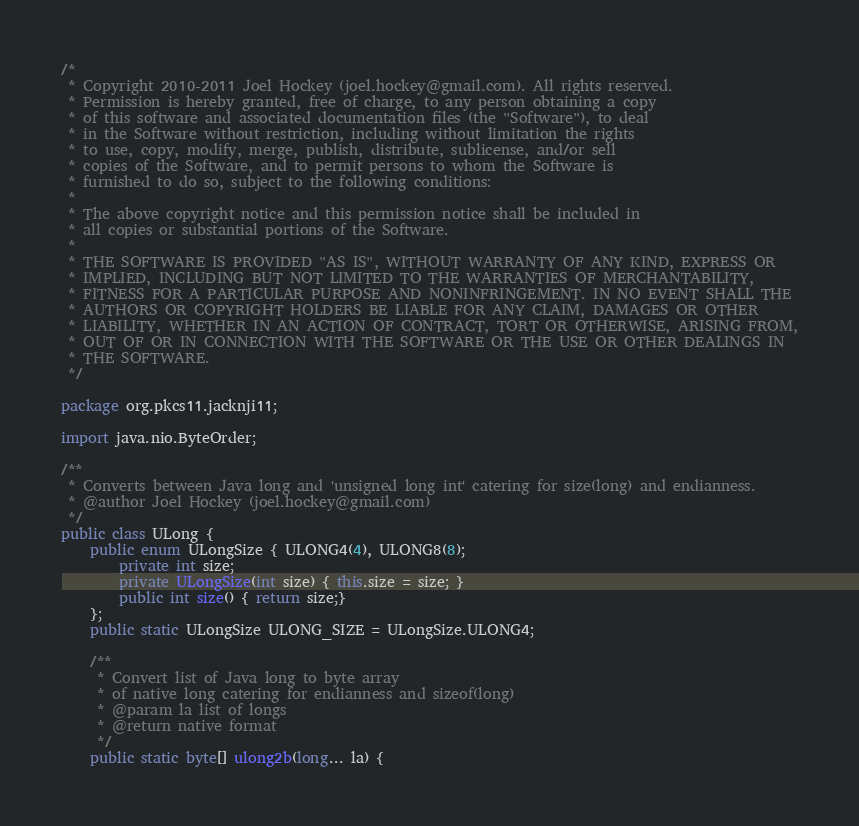Convert code to text. <code><loc_0><loc_0><loc_500><loc_500><_Java_>/*
 * Copyright 2010-2011 Joel Hockey (joel.hockey@gmail.com). All rights reserved.
 * Permission is hereby granted, free of charge, to any person obtaining a copy
 * of this software and associated documentation files (the "Software"), to deal
 * in the Software without restriction, including without limitation the rights
 * to use, copy, modify, merge, publish, distribute, sublicense, and/or sell
 * copies of the Software, and to permit persons to whom the Software is
 * furnished to do so, subject to the following conditions:
 *
 * The above copyright notice and this permission notice shall be included in
 * all copies or substantial portions of the Software.
 *
 * THE SOFTWARE IS PROVIDED "AS IS", WITHOUT WARRANTY OF ANY KIND, EXPRESS OR
 * IMPLIED, INCLUDING BUT NOT LIMITED TO THE WARRANTIES OF MERCHANTABILITY,
 * FITNESS FOR A PARTICULAR PURPOSE AND NONINFRINGEMENT. IN NO EVENT SHALL THE
 * AUTHORS OR COPYRIGHT HOLDERS BE LIABLE FOR ANY CLAIM, DAMAGES OR OTHER
 * LIABILITY, WHETHER IN AN ACTION OF CONTRACT, TORT OR OTHERWISE, ARISING FROM,
 * OUT OF OR IN CONNECTION WITH THE SOFTWARE OR THE USE OR OTHER DEALINGS IN
 * THE SOFTWARE.
 */

package org.pkcs11.jacknji11;

import java.nio.ByteOrder;

/**
 * Converts between Java long and 'unsigned long int' catering for size(long) and endianness.
 * @author Joel Hockey (joel.hockey@gmail.com)
 */
public class ULong {
    public enum ULongSize { ULONG4(4), ULONG8(8);
        private int size;
        private ULongSize(int size) { this.size = size; }
        public int size() { return size;}
    };
    public static ULongSize ULONG_SIZE = ULongSize.ULONG4;

    /**
     * Convert list of Java long to byte array
     * of native long catering for endianness and sizeof(long)
     * @param la list of longs
     * @return native format
     */
    public static byte[] ulong2b(long... la) {</code> 